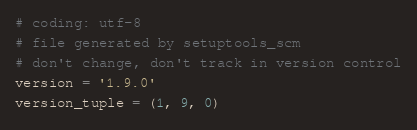<code> <loc_0><loc_0><loc_500><loc_500><_Python_># coding: utf-8
# file generated by setuptools_scm
# don't change, don't track in version control
version = '1.9.0'
version_tuple = (1, 9, 0)
</code> 